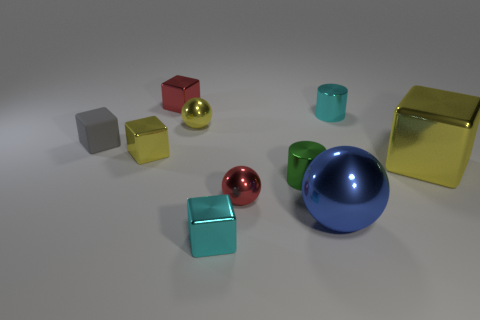What number of things are tiny blocks that are behind the tiny rubber block or balls to the right of the gray rubber object?
Offer a very short reply. 4. The tiny rubber cube is what color?
Make the answer very short. Gray. Are there fewer tiny yellow metal blocks on the left side of the green thing than small red things?
Provide a succinct answer. Yes. Is there anything else that has the same shape as the small gray thing?
Ensure brevity in your answer.  Yes. Is there a large brown metallic ball?
Your answer should be very brief. No. Are there fewer yellow shiny objects than cyan metal cubes?
Make the answer very short. No. What number of blue objects have the same material as the small red sphere?
Offer a terse response. 1. The big sphere that is the same material as the large yellow block is what color?
Keep it short and to the point. Blue. What is the shape of the blue metallic thing?
Give a very brief answer. Sphere. How many metallic objects have the same color as the large ball?
Give a very brief answer. 0. 